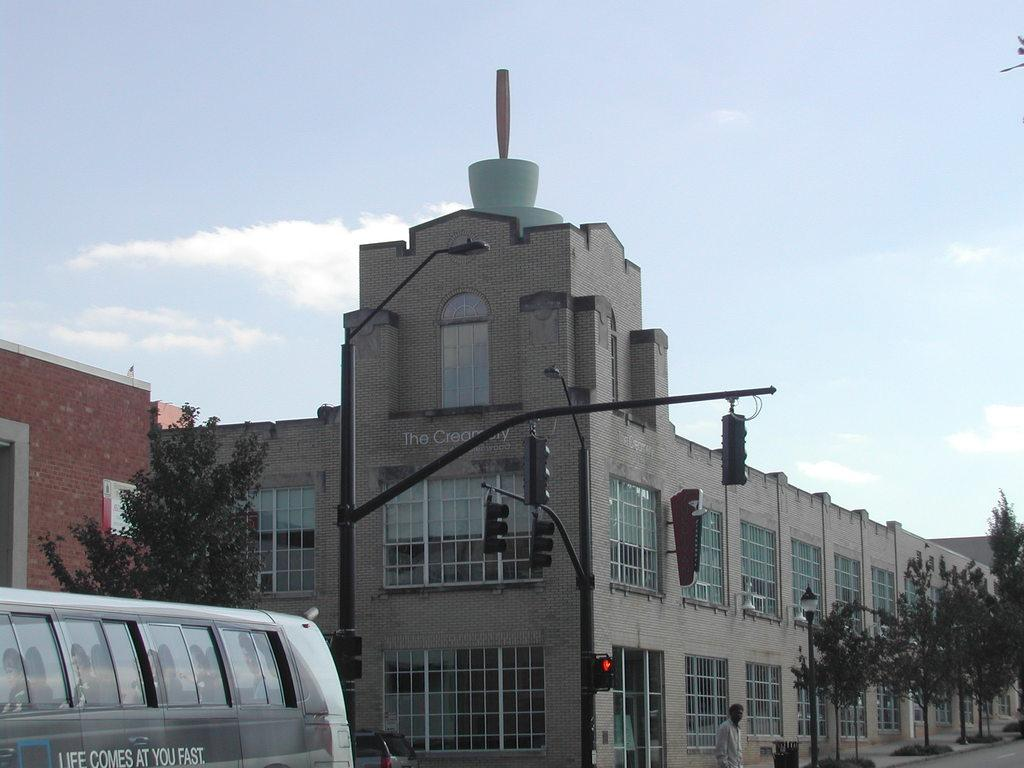What is the main subject in the image? There is a person standing in the image. What else can be seen in the image besides the person? There are vehicles, lights, traffic signals on poles, a building, a wall, trees, and the sky visible in the background of the image. What type of carriage is being used for digestion in the image? There is no carriage or digestion-related activity present in the image. 